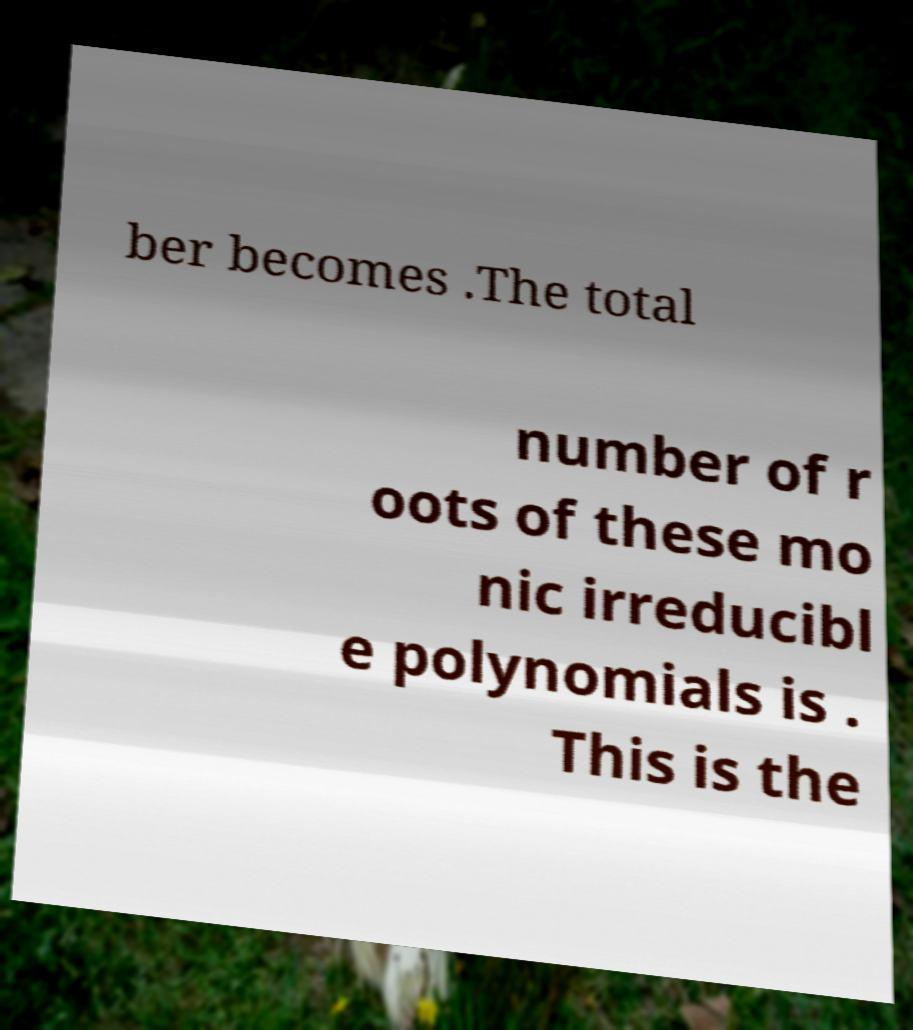Please identify and transcribe the text found in this image. ber becomes .The total number of r oots of these mo nic irreducibl e polynomials is . This is the 